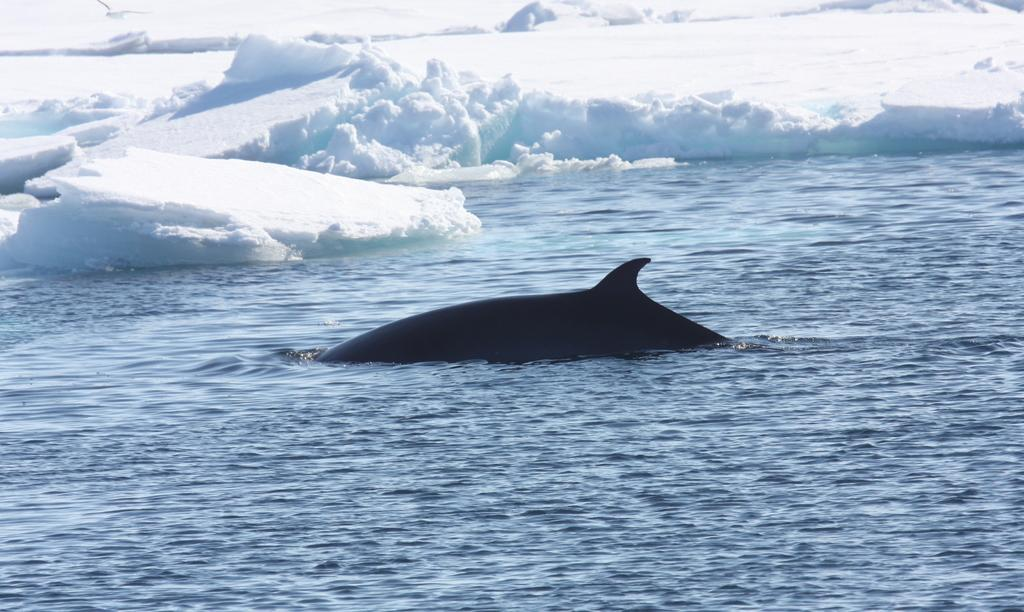What is the main setting of the picture? There is an ocean in the picture. What type of animal can be seen in the picture? There is a fish in the picture. What is the predominant feature of the ocean in the picture? There is a lot of ice in the picture. What is the primary substance visible in the picture? There is water visible in the picture. What is the bird in the picture doing? There is a bird flying in the picture. What type of frame is visible around the ocean in the picture? There is no frame visible around the ocean in the picture; it is a photograph or illustration of the ocean itself. 